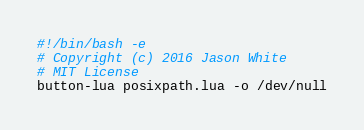Convert code to text. <code><loc_0><loc_0><loc_500><loc_500><_Bash_>#!/bin/bash -e
# Copyright (c) 2016 Jason White
# MIT License
button-lua posixpath.lua -o /dev/null
</code> 